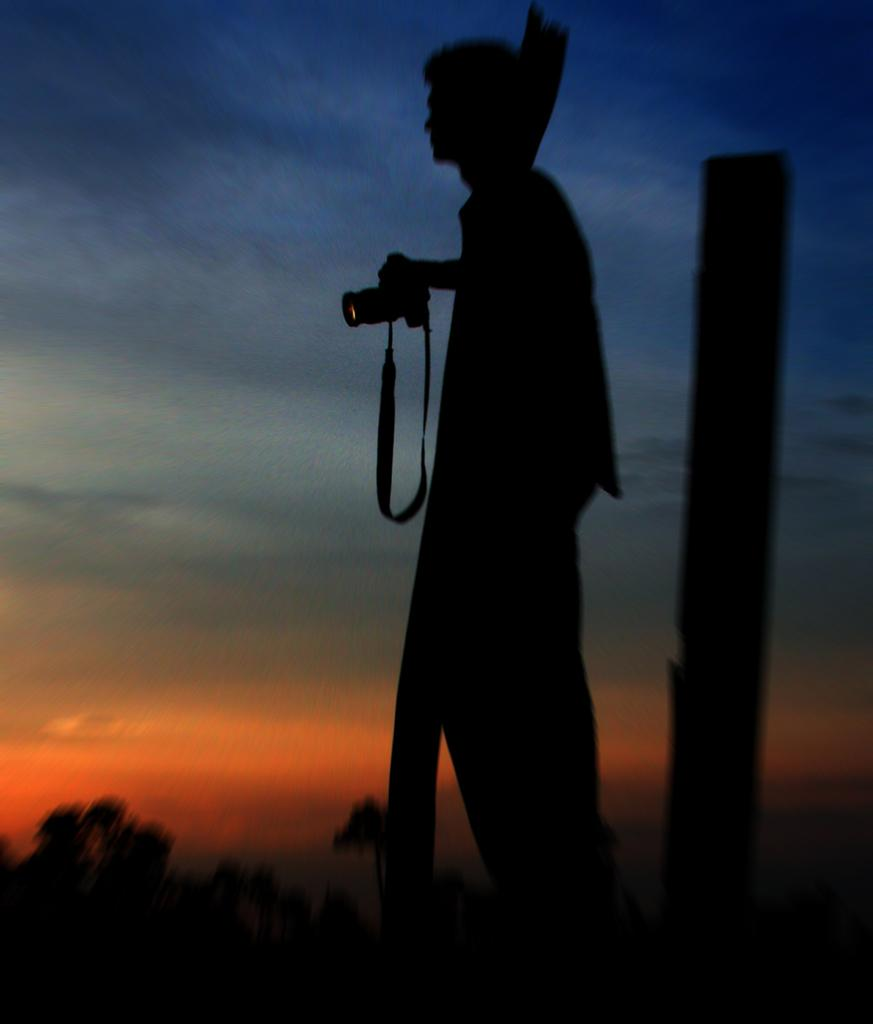Who is present in the image? There is a person in the image. What is the person doing in the image? The person is standing in front and holding a camera. What can be seen in the background of the image? The sky is visible in the background of the image. How would you describe the lighting in the image? The image appears to be a bit dark. Can you see any volcanoes in the image? No, there are no volcanoes present in the image. What type of request is the person making in the image? There is no indication of a request being made in the image; the person is simply standing and holding a camera. 